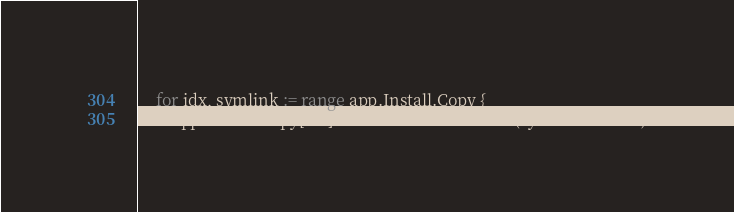Convert code to text. <code><loc_0><loc_0><loc_500><loc_500><_Go_>	for idx, symlink := range app.Install.Copy {
		app.Install.Copy[idx].Source = substituteEnv(symlink.Source)</code> 